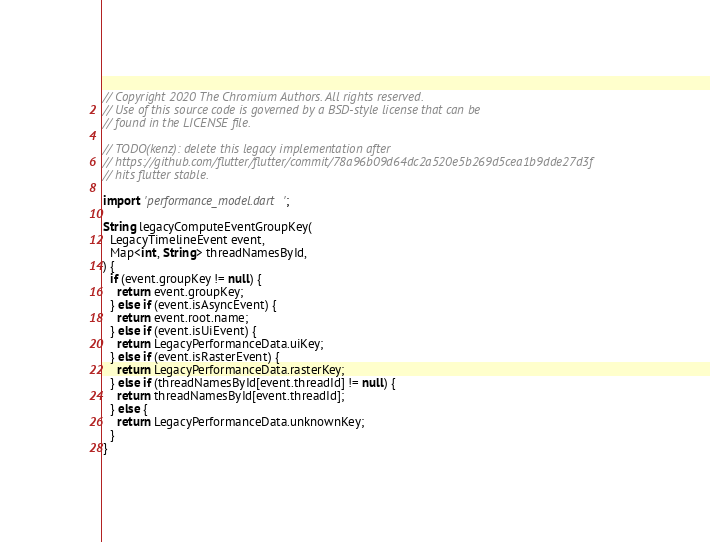Convert code to text. <code><loc_0><loc_0><loc_500><loc_500><_Dart_>// Copyright 2020 The Chromium Authors. All rights reserved.
// Use of this source code is governed by a BSD-style license that can be
// found in the LICENSE file.

// TODO(kenz): delete this legacy implementation after
// https://github.com/flutter/flutter/commit/78a96b09d64dc2a520e5b269d5cea1b9dde27d3f
// hits flutter stable.

import 'performance_model.dart';

String legacyComputeEventGroupKey(
  LegacyTimelineEvent event,
  Map<int, String> threadNamesById,
) {
  if (event.groupKey != null) {
    return event.groupKey;
  } else if (event.isAsyncEvent) {
    return event.root.name;
  } else if (event.isUiEvent) {
    return LegacyPerformanceData.uiKey;
  } else if (event.isRasterEvent) {
    return LegacyPerformanceData.rasterKey;
  } else if (threadNamesById[event.threadId] != null) {
    return threadNamesById[event.threadId];
  } else {
    return LegacyPerformanceData.unknownKey;
  }
}
</code> 